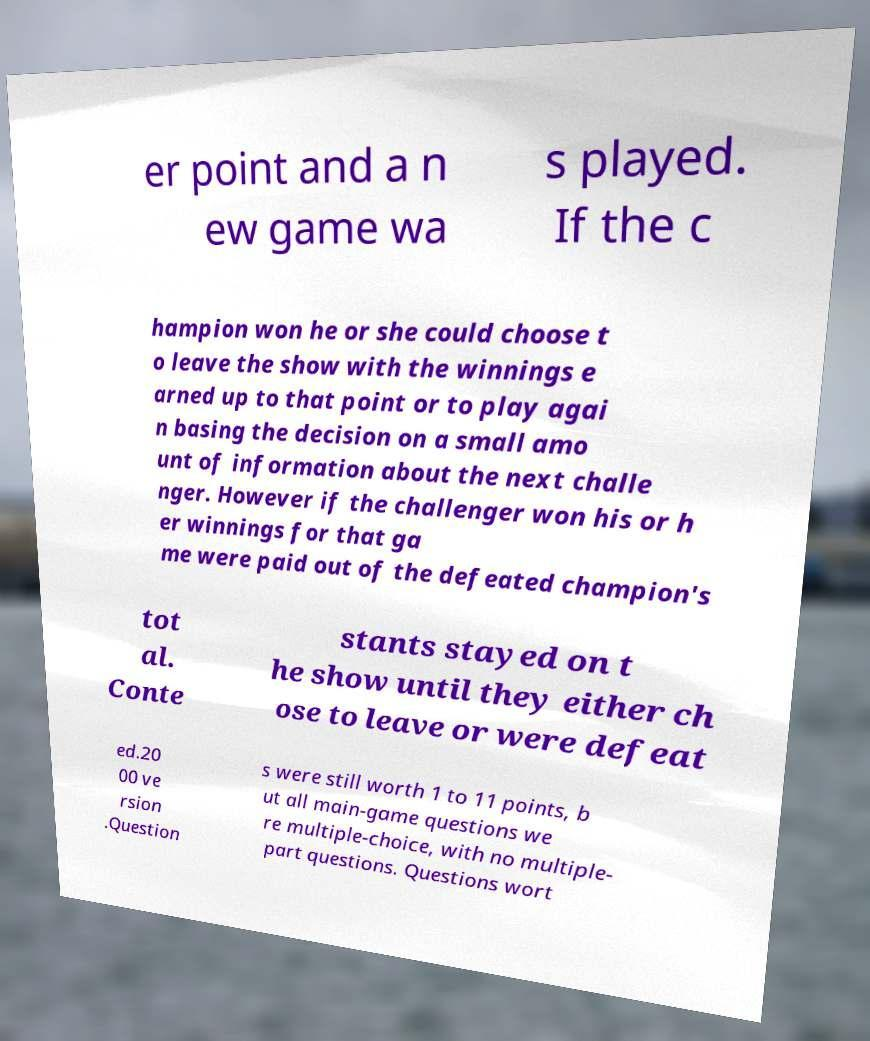I need the written content from this picture converted into text. Can you do that? er point and a n ew game wa s played. If the c hampion won he or she could choose t o leave the show with the winnings e arned up to that point or to play agai n basing the decision on a small amo unt of information about the next challe nger. However if the challenger won his or h er winnings for that ga me were paid out of the defeated champion's tot al. Conte stants stayed on t he show until they either ch ose to leave or were defeat ed.20 00 ve rsion .Question s were still worth 1 to 11 points, b ut all main-game questions we re multiple-choice, with no multiple- part questions. Questions wort 